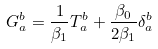<formula> <loc_0><loc_0><loc_500><loc_500>G ^ { b } _ { a } = \frac { 1 } { \beta _ { 1 } } T ^ { b } _ { a } + \frac { \beta _ { 0 } } { 2 \beta _ { 1 } } \delta ^ { b } _ { a }</formula> 